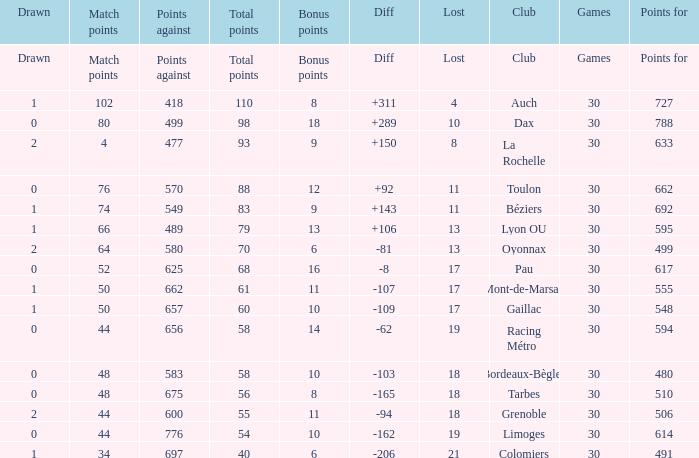What is the value of match points when the points for is 570? 76.0. 